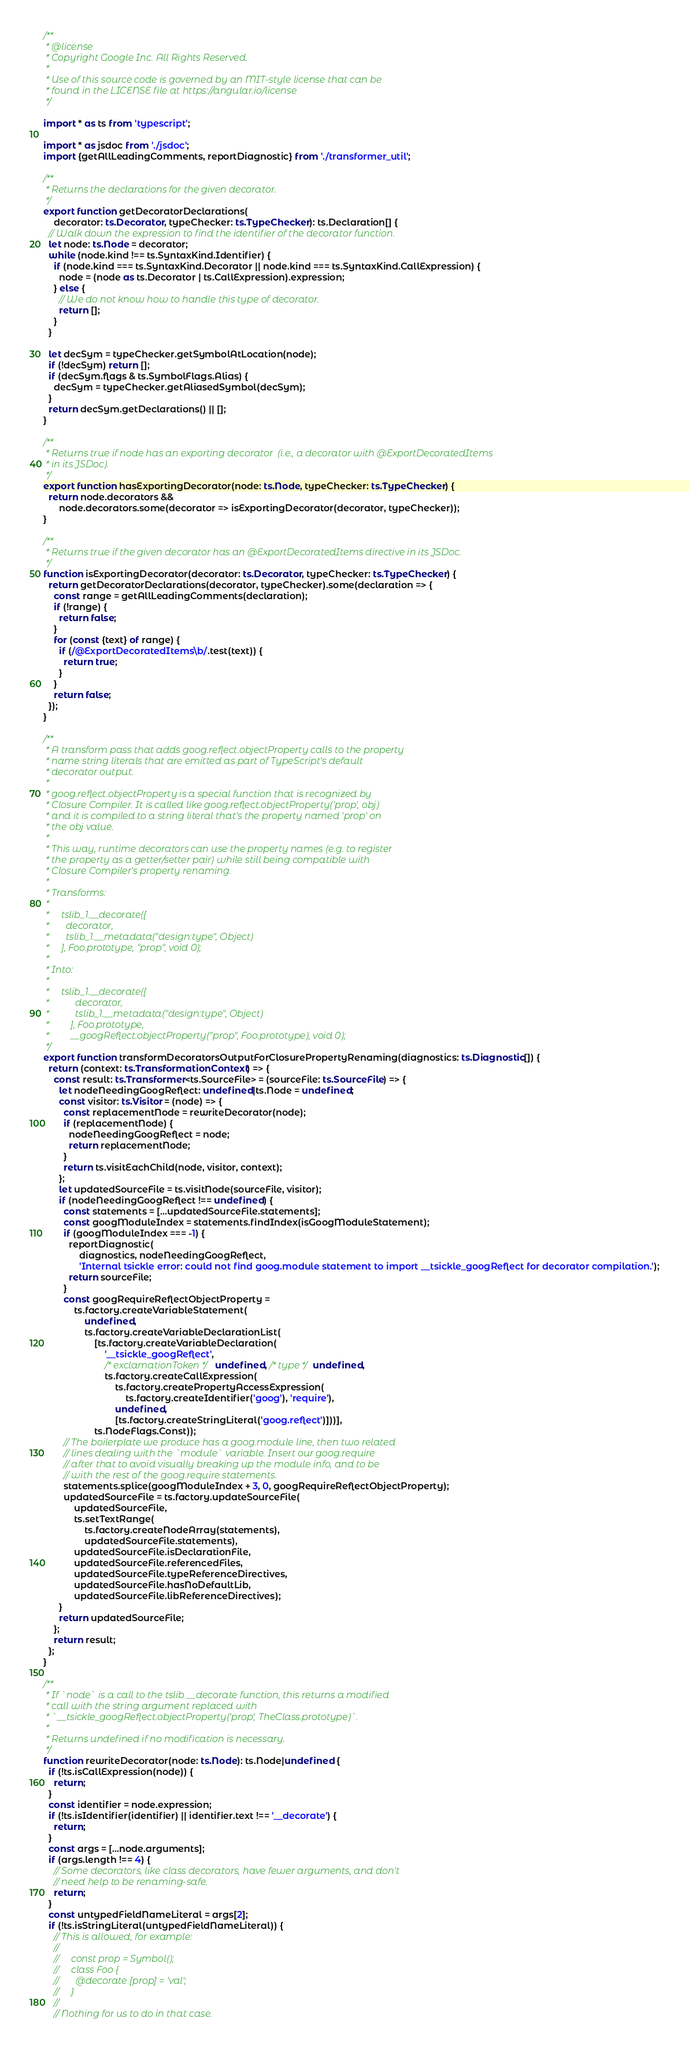<code> <loc_0><loc_0><loc_500><loc_500><_TypeScript_>/**
 * @license
 * Copyright Google Inc. All Rights Reserved.
 *
 * Use of this source code is governed by an MIT-style license that can be
 * found in the LICENSE file at https://angular.io/license
 */

import * as ts from 'typescript';

import * as jsdoc from './jsdoc';
import {getAllLeadingComments, reportDiagnostic} from './transformer_util';

/**
 * Returns the declarations for the given decorator.
 */
export function getDecoratorDeclarations(
    decorator: ts.Decorator, typeChecker: ts.TypeChecker): ts.Declaration[] {
  // Walk down the expression to find the identifier of the decorator function.
  let node: ts.Node = decorator;
  while (node.kind !== ts.SyntaxKind.Identifier) {
    if (node.kind === ts.SyntaxKind.Decorator || node.kind === ts.SyntaxKind.CallExpression) {
      node = (node as ts.Decorator | ts.CallExpression).expression;
    } else {
      // We do not know how to handle this type of decorator.
      return [];
    }
  }

  let decSym = typeChecker.getSymbolAtLocation(node);
  if (!decSym) return [];
  if (decSym.flags & ts.SymbolFlags.Alias) {
    decSym = typeChecker.getAliasedSymbol(decSym);
  }
  return decSym.getDeclarations() || [];
}

/**
 * Returns true if node has an exporting decorator  (i.e., a decorator with @ExportDecoratedItems
 * in its JSDoc).
 */
export function hasExportingDecorator(node: ts.Node, typeChecker: ts.TypeChecker) {
  return node.decorators &&
      node.decorators.some(decorator => isExportingDecorator(decorator, typeChecker));
}

/**
 * Returns true if the given decorator has an @ExportDecoratedItems directive in its JSDoc.
 */
function isExportingDecorator(decorator: ts.Decorator, typeChecker: ts.TypeChecker) {
  return getDecoratorDeclarations(decorator, typeChecker).some(declaration => {
    const range = getAllLeadingComments(declaration);
    if (!range) {
      return false;
    }
    for (const {text} of range) {
      if (/@ExportDecoratedItems\b/.test(text)) {
        return true;
      }
    }
    return false;
  });
}

/**
 * A transform pass that adds goog.reflect.objectProperty calls to the property
 * name string literals that are emitted as part of TypeScript's default
 * decorator output.
 *
 * goog.reflect.objectProperty is a special function that is recognized by
 * Closure Compiler. It is called like goog.reflect.objectProperty('prop', obj)
 * and it is compiled to a string literal that's the property named 'prop' on
 * the obj value.
 *
 * This way, runtime decorators can use the property names (e.g. to register
 * the property as a getter/setter pair) while still being compatible with
 * Closure Compiler's property renaming.
 *
 * Transforms:
 *
 *     tslib_1.__decorate([
 *       decorator,
 *       tslib_1.__metadata("design:type", Object)
 *     ], Foo.prototype, "prop", void 0);
 *
 * Into:
 *
 *     tslib_1.__decorate([
 *           decorator,
 *           tslib_1.__metadata("design:type", Object)
 *         ], Foo.prototype,
 *         __googReflect.objectProperty("prop", Foo.prototype), void 0);
 */
export function transformDecoratorsOutputForClosurePropertyRenaming(diagnostics: ts.Diagnostic[]) {
  return (context: ts.TransformationContext) => {
    const result: ts.Transformer<ts.SourceFile> = (sourceFile: ts.SourceFile) => {
      let nodeNeedingGoogReflect: undefined|ts.Node = undefined;
      const visitor: ts.Visitor = (node) => {
        const replacementNode = rewriteDecorator(node);
        if (replacementNode) {
          nodeNeedingGoogReflect = node;
          return replacementNode;
        }
        return ts.visitEachChild(node, visitor, context);
      };
      let updatedSourceFile = ts.visitNode(sourceFile, visitor);
      if (nodeNeedingGoogReflect !== undefined) {
        const statements = [...updatedSourceFile.statements];
        const googModuleIndex = statements.findIndex(isGoogModuleStatement);
        if (googModuleIndex === -1) {
          reportDiagnostic(
              diagnostics, nodeNeedingGoogReflect,
              'Internal tsickle error: could not find goog.module statement to import __tsickle_googReflect for decorator compilation.');
          return sourceFile;
        }
        const googRequireReflectObjectProperty =
            ts.factory.createVariableStatement(
                undefined,
                ts.factory.createVariableDeclarationList(
                    [ts.factory.createVariableDeclaration(
                        '__tsickle_googReflect',
                        /* exclamationToken */ undefined, /* type */ undefined,
                        ts.factory.createCallExpression(
                            ts.factory.createPropertyAccessExpression(
                                ts.factory.createIdentifier('goog'), 'require'),
                            undefined,
                            [ts.factory.createStringLiteral('goog.reflect')]))],
                    ts.NodeFlags.Const));
        // The boilerplate we produce has a goog.module line, then two related
        // lines dealing with the `module` variable. Insert our goog.require
        // after that to avoid visually breaking up the module info, and to be
        // with the rest of the goog.require statements.
        statements.splice(googModuleIndex + 3, 0, googRequireReflectObjectProperty);
        updatedSourceFile = ts.factory.updateSourceFile(
            updatedSourceFile,
            ts.setTextRange(
                ts.factory.createNodeArray(statements),
                updatedSourceFile.statements),
            updatedSourceFile.isDeclarationFile,
            updatedSourceFile.referencedFiles,
            updatedSourceFile.typeReferenceDirectives,
            updatedSourceFile.hasNoDefaultLib,
            updatedSourceFile.libReferenceDirectives);
      }
      return updatedSourceFile;
    };
    return result;
  };
}

/**
 * If `node` is a call to the tslib __decorate function, this returns a modified
 * call with the string argument replaced with
 * `__tsickle_googReflect.objectProperty('prop', TheClass.prototype)`.
 *
 * Returns undefined if no modification is necessary.
 */
function rewriteDecorator(node: ts.Node): ts.Node|undefined {
  if (!ts.isCallExpression(node)) {
    return;
  }
  const identifier = node.expression;
  if (!ts.isIdentifier(identifier) || identifier.text !== '__decorate') {
    return;
  }
  const args = [...node.arguments];
  if (args.length !== 4) {
    // Some decorators, like class decorators, have fewer arguments, and don't
    // need help to be renaming-safe.
    return;
  }
  const untypedFieldNameLiteral = args[2];
  if (!ts.isStringLiteral(untypedFieldNameLiteral)) {
    // This is allowed, for example:
    //
    //     const prop = Symbol();
    //     class Foo {
    //       @decorate [prop] = 'val';
    //     }
    //
    // Nothing for us to do in that case.</code> 